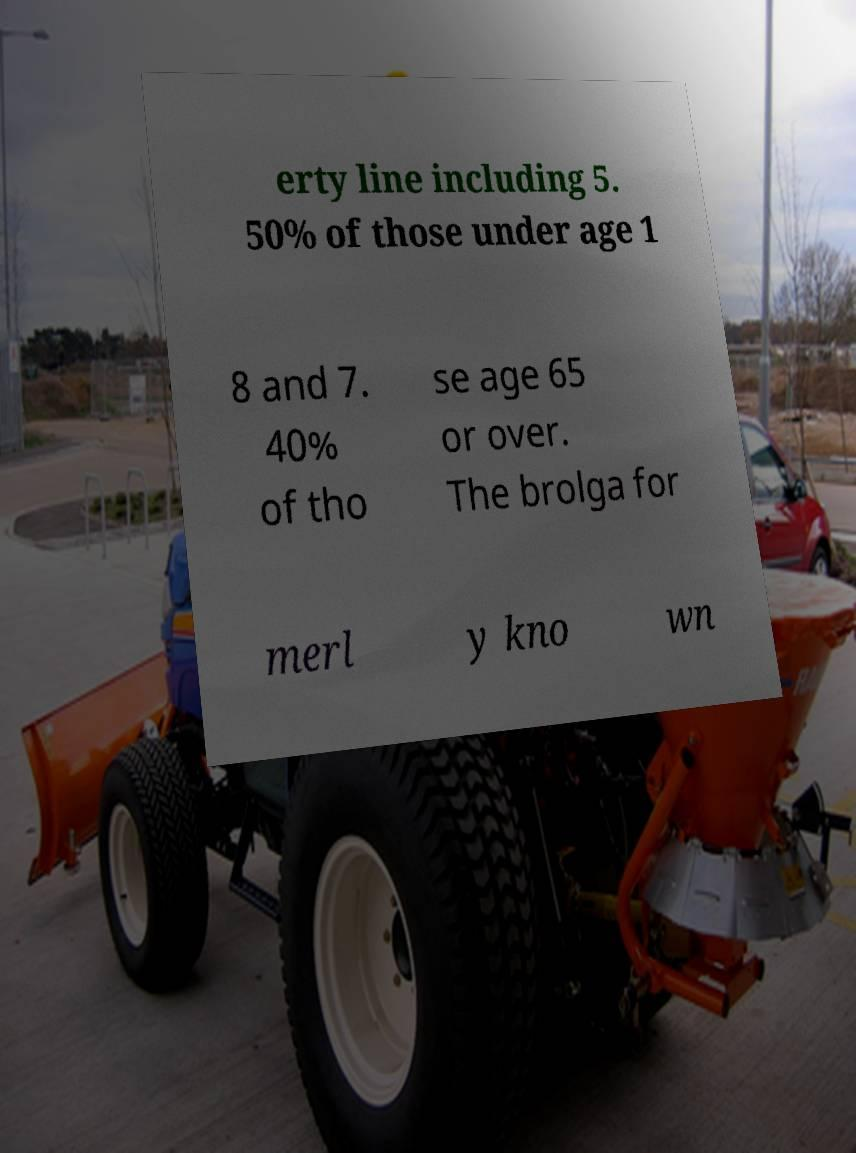Please identify and transcribe the text found in this image. erty line including 5. 50% of those under age 1 8 and 7. 40% of tho se age 65 or over. The brolga for merl y kno wn 